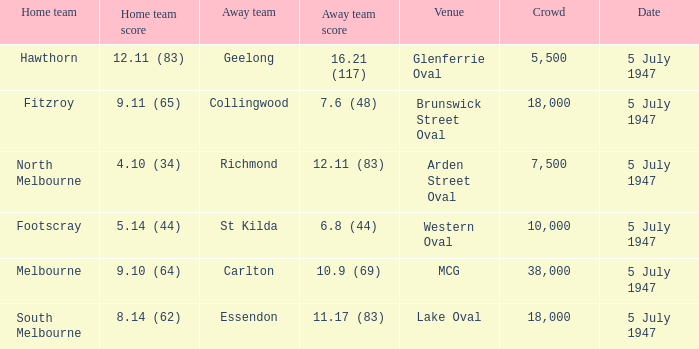Who was the away team when North Melbourne was the home team? Richmond. 